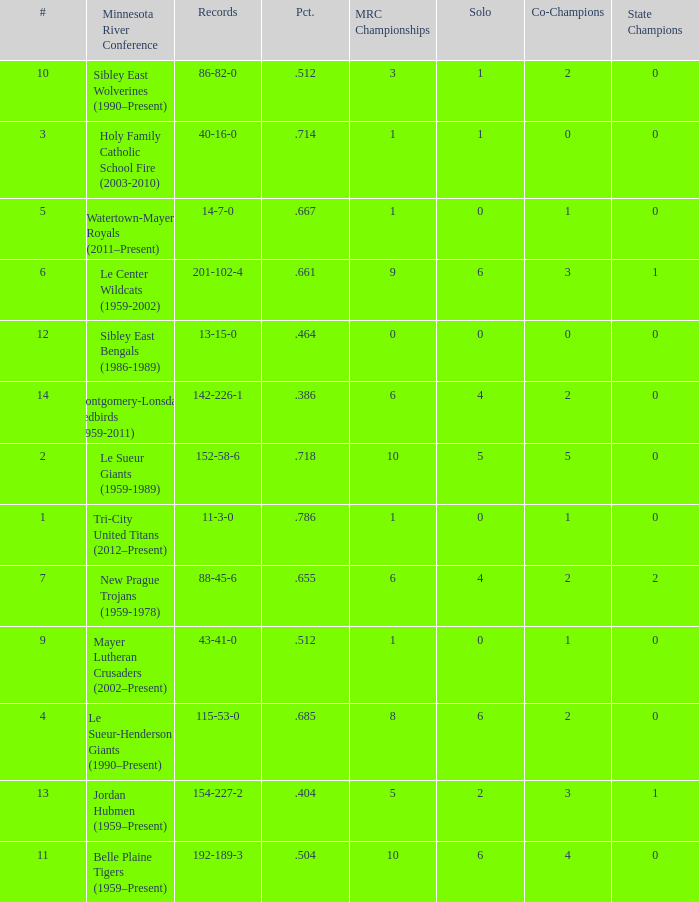How many teams are #2 on the list? 1.0. 